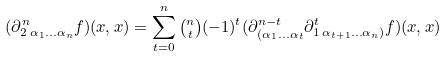<formula> <loc_0><loc_0><loc_500><loc_500>( \partial _ { 2 \, \alpha _ { 1 } \dots \alpha _ { n } } ^ { n } f ) ( x , x ) = \sum _ { t = 0 } ^ { n } \tbinom { n } { t } ( - 1 ) ^ { t } ( \partial ^ { n - t } _ { ( \alpha _ { 1 } \dots \alpha _ { t } } \partial _ { 1 \, \alpha _ { t + 1 } \dots \alpha _ { n } ) } ^ { t } f ) ( x , x )</formula> 